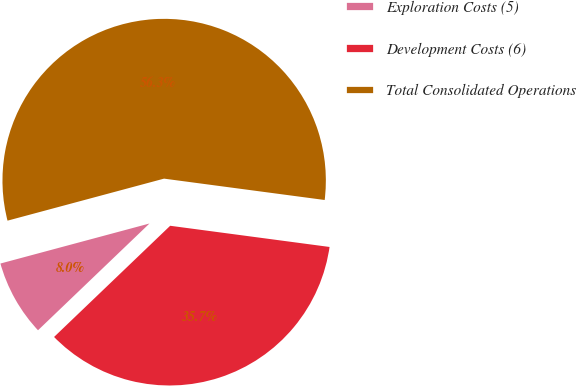Convert chart. <chart><loc_0><loc_0><loc_500><loc_500><pie_chart><fcel>Exploration Costs (5)<fcel>Development Costs (6)<fcel>Total Consolidated Operations<nl><fcel>7.98%<fcel>35.74%<fcel>56.28%<nl></chart> 